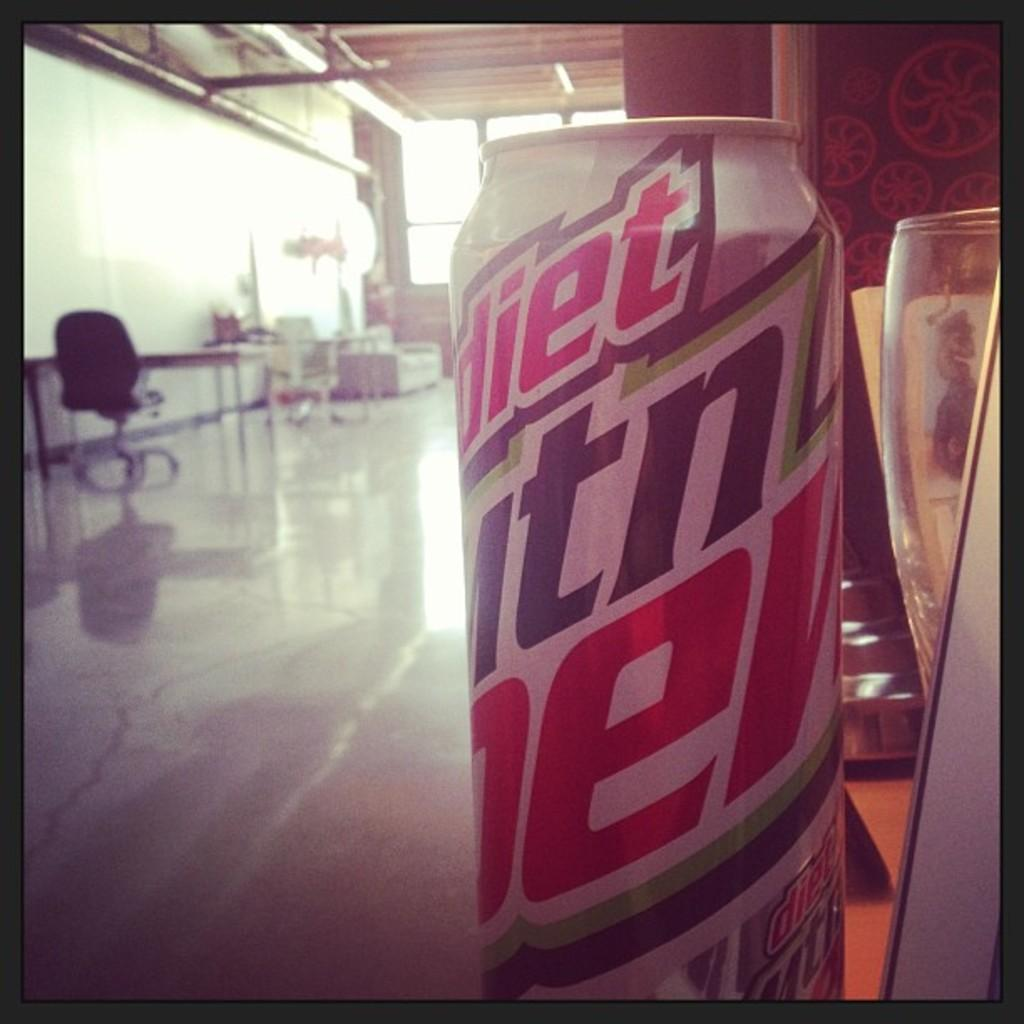<image>
Present a compact description of the photo's key features. A can of Mountain Dew is shown in an office room. 